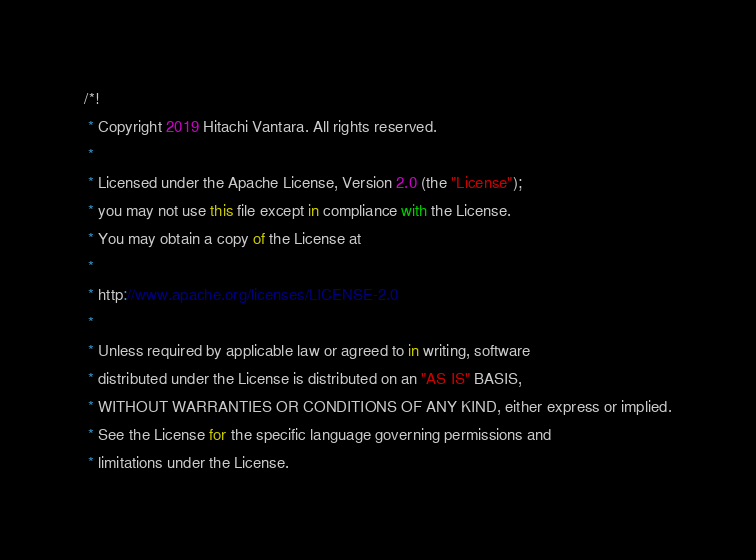<code> <loc_0><loc_0><loc_500><loc_500><_JavaScript_>/*!
 * Copyright 2019 Hitachi Vantara. All rights reserved.
 *
 * Licensed under the Apache License, Version 2.0 (the "License");
 * you may not use this file except in compliance with the License.
 * You may obtain a copy of the License at
 *
 * http://www.apache.org/licenses/LICENSE-2.0
 *
 * Unless required by applicable law or agreed to in writing, software
 * distributed under the License is distributed on an "AS IS" BASIS,
 * WITHOUT WARRANTIES OR CONDITIONS OF ANY KIND, either express or implied.
 * See the License for the specific language governing permissions and
 * limitations under the License.</code> 